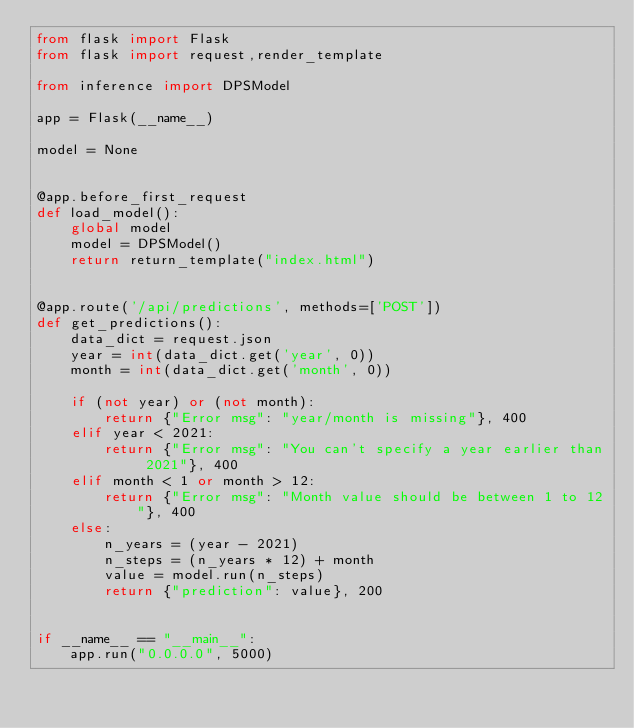Convert code to text. <code><loc_0><loc_0><loc_500><loc_500><_Python_>from flask import Flask
from flask import request,render_template

from inference import DPSModel

app = Flask(__name__)

model = None


@app.before_first_request
def load_model():
    global model
    model = DPSModel()
    return return_template("index.html")


@app.route('/api/predictions', methods=['POST'])
def get_predictions():
    data_dict = request.json
    year = int(data_dict.get('year', 0))
    month = int(data_dict.get('month', 0))

    if (not year) or (not month):
        return {"Error msg": "year/month is missing"}, 400
    elif year < 2021:
        return {"Error msg": "You can't specify a year earlier than 2021"}, 400
    elif month < 1 or month > 12:
        return {"Error msg": "Month value should be between 1 to 12"}, 400
    else:
        n_years = (year - 2021)
        n_steps = (n_years * 12) + month
        value = model.run(n_steps)
        return {"prediction": value}, 200


if __name__ == "__main__":
    app.run("0.0.0.0", 5000)
</code> 